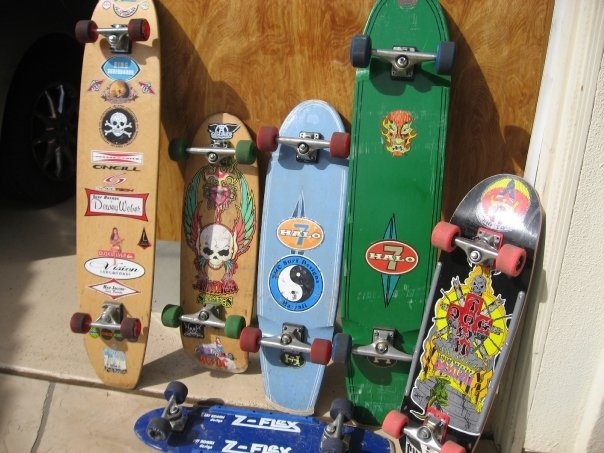Describe the objects in this image and their specific colors. I can see skateboard in black, darkgreen, and green tones, skateboard in black, tan, lightgray, and gray tones, skateboard in black, darkgray, gray, and lightgray tones, skateboard in black, lightblue, darkgray, and lightgray tones, and skateboard in black, gray, maroon, and tan tones in this image. 